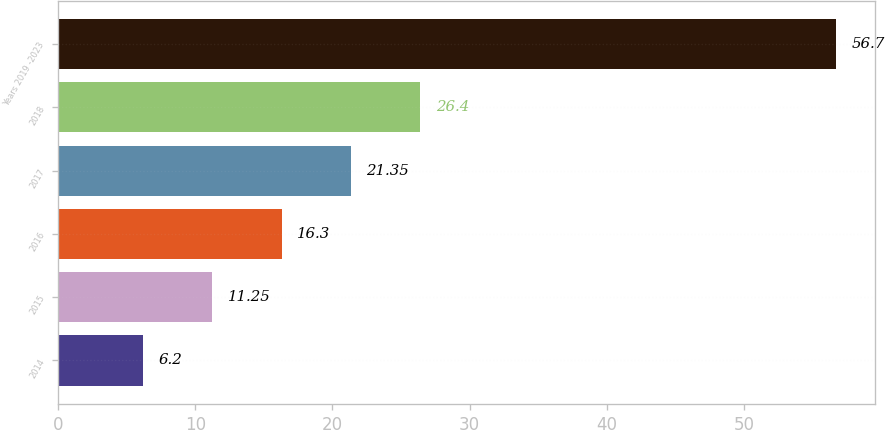<chart> <loc_0><loc_0><loc_500><loc_500><bar_chart><fcel>2014<fcel>2015<fcel>2016<fcel>2017<fcel>2018<fcel>Years 2019 -2023<nl><fcel>6.2<fcel>11.25<fcel>16.3<fcel>21.35<fcel>26.4<fcel>56.7<nl></chart> 